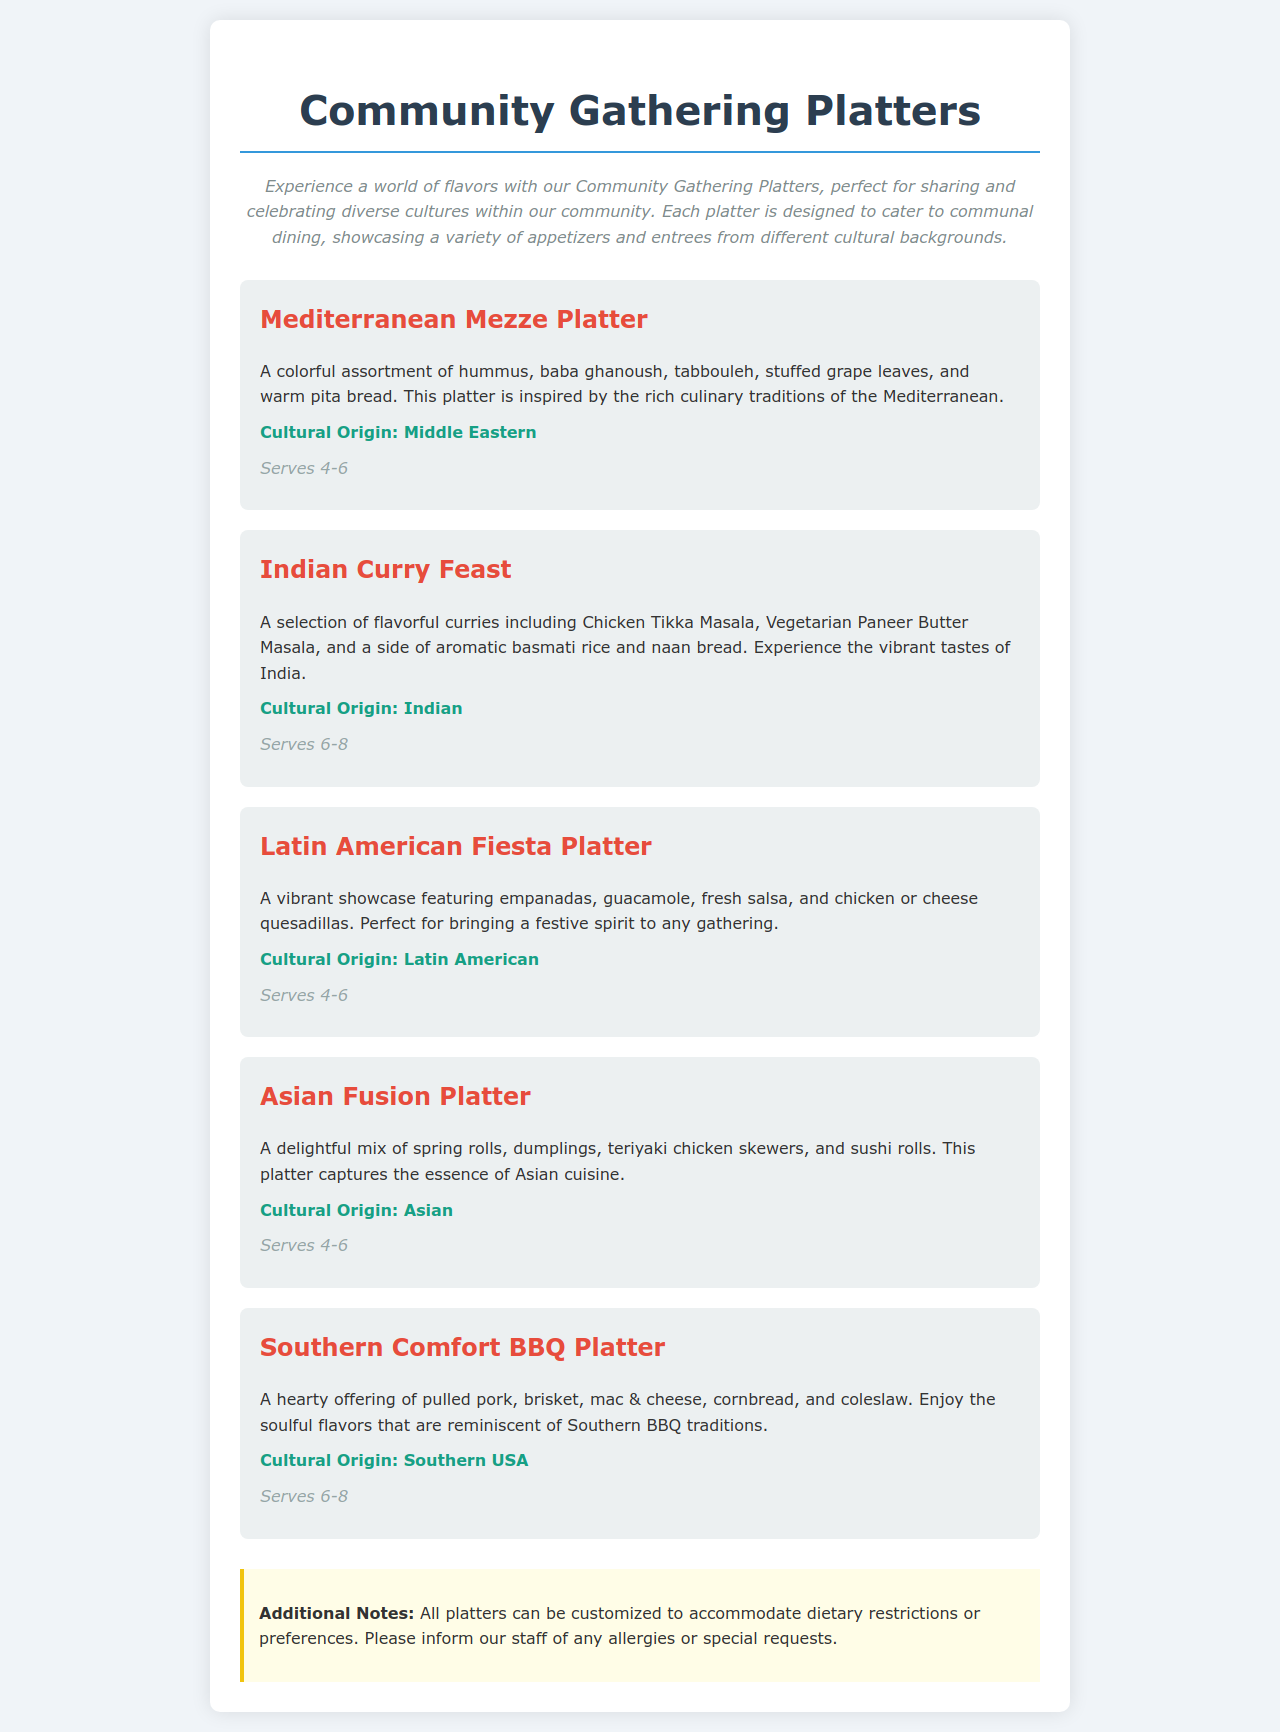What is the title of the menu? The title of the menu is prominently displayed at the top of the document, indicating the theme of the offerings.
Answer: Community Gathering Platters How many servings does the Mediterranean Mezze Platter provide? The number of servings for the Mediterranean Mezze Platter is mentioned directly under its description.
Answer: Serves 4-6 What is included in the Indian Curry Feast platter? The Indian Curry Feast platter description lists the specific dishes contained within it, highlighting the variety offered.
Answer: Chicken Tikka Masala, Vegetarian Paneer Butter Masala, basmati rice, naan bread What cultural origin is associated with the Asian Fusion Platter? The cultural origin indicates the geographical background of the cuisine represented in the platter description.
Answer: Asian Which platter serves the most people? The number of servings specified in the platter descriptions allows for comparison, identifying the one that serves the largest group.
Answer: Southern Comfort BBQ Platter (Serves 6-8) What additional notes are given regarding dietary restrictions? Additional notes are provided in a specific section, emphasizing the restaurant's flexibility and sensitivity towards dietary needs.
Answer: All platters can be customized to accommodate dietary restrictions or preferences How many types of cuisine are showcased in the Community Gathering Platters? The document lists separate platters representing different cultural backgrounds, allowing for a count of distinct cuisines.
Answer: Five What is the description style used for the platters? The document features a specific font style dedicated to enhancing the visibility and attraction of the platter descriptions.
Answer: Bold and colored for emphasis 